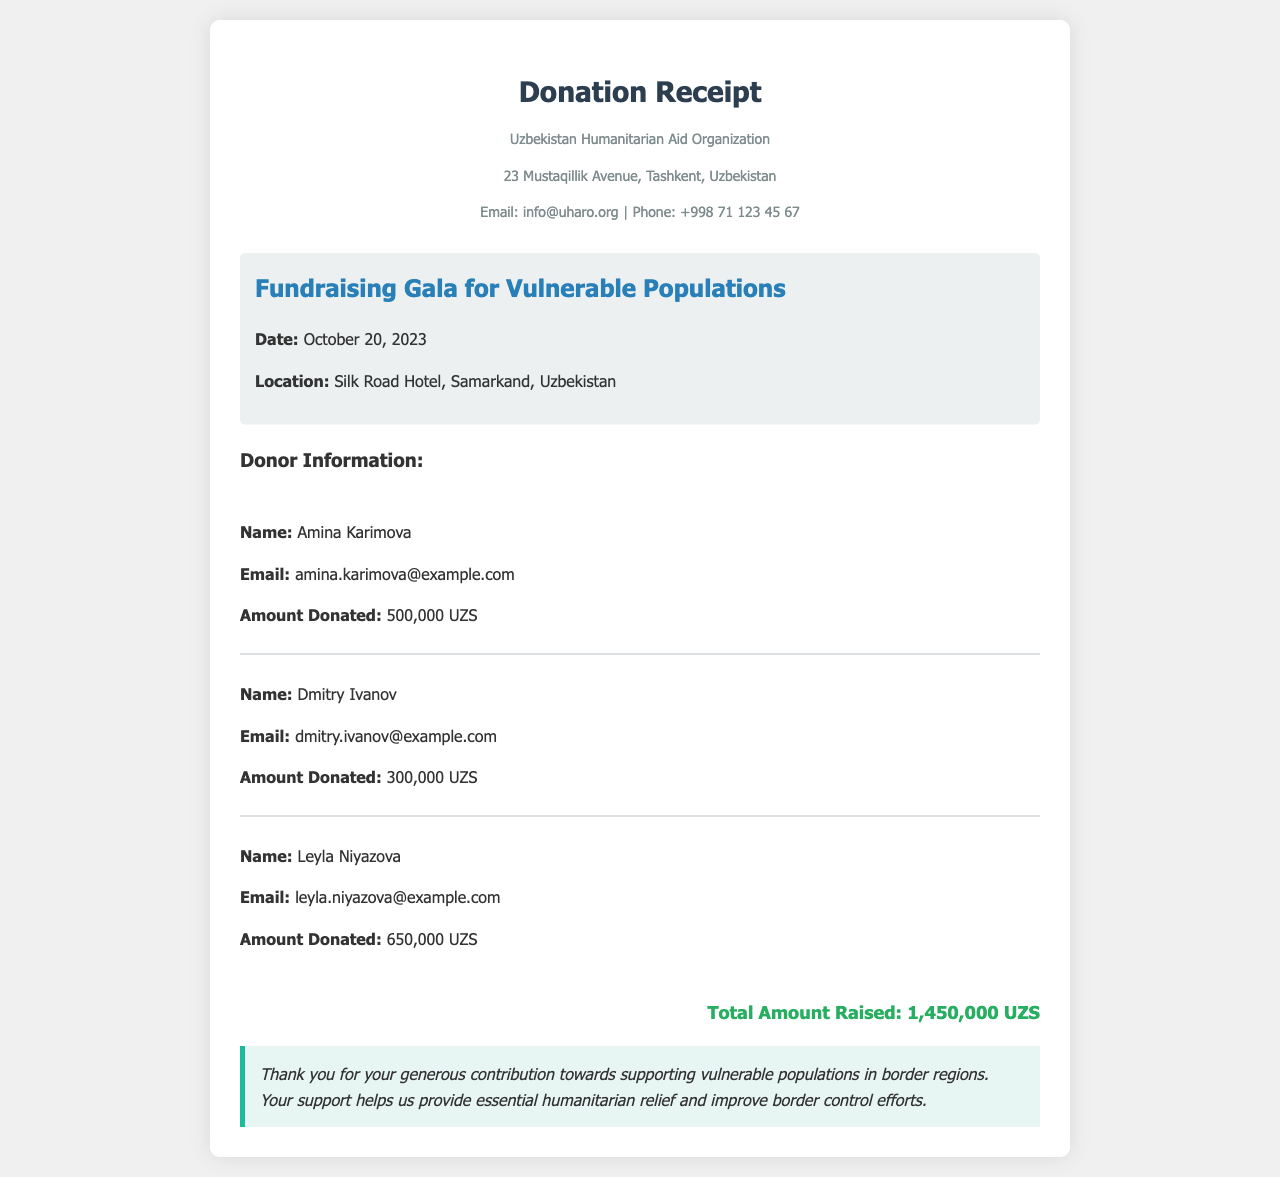what is the total amount raised? The total amount raised is summarized in the document, which lists all the donations received.
Answer: 1,450,000 UZS who is the first donor listed? The first donor's information is presented at the top of the donor list in the document.
Answer: Amina Karimova what is the email address of the second donor? The email of the second donor is included in their details in the document.
Answer: dmitry.ivanov@example.com when did the fundraising gala take place? The date of the fundraising event is stated prominently in the event information section of the document.
Answer: October 20, 2023 where was the fundraising gala held? The location of the event is specified in the document under event information.
Answer: Silk Road Hotel, Samarkand, Uzbekistan how many donors contributed? The document lists the individual donors, allowing for a count of the total contributors.
Answer: 3 what is the primary purpose of the fundraising event? The purpose of the event is mentioned in the messaging section of the document.
Answer: Supporting vulnerable populations in border regions which organization issued the donation receipt? The name of the organization that created the receipt is provided at the top of the document.
Answer: Uzbekistan Humanitarian Aid Organization what was the amount donated by Leyla Niyazova? The document specifies the individual donation amounts for each donor clearly.
Answer: 650,000 UZS 